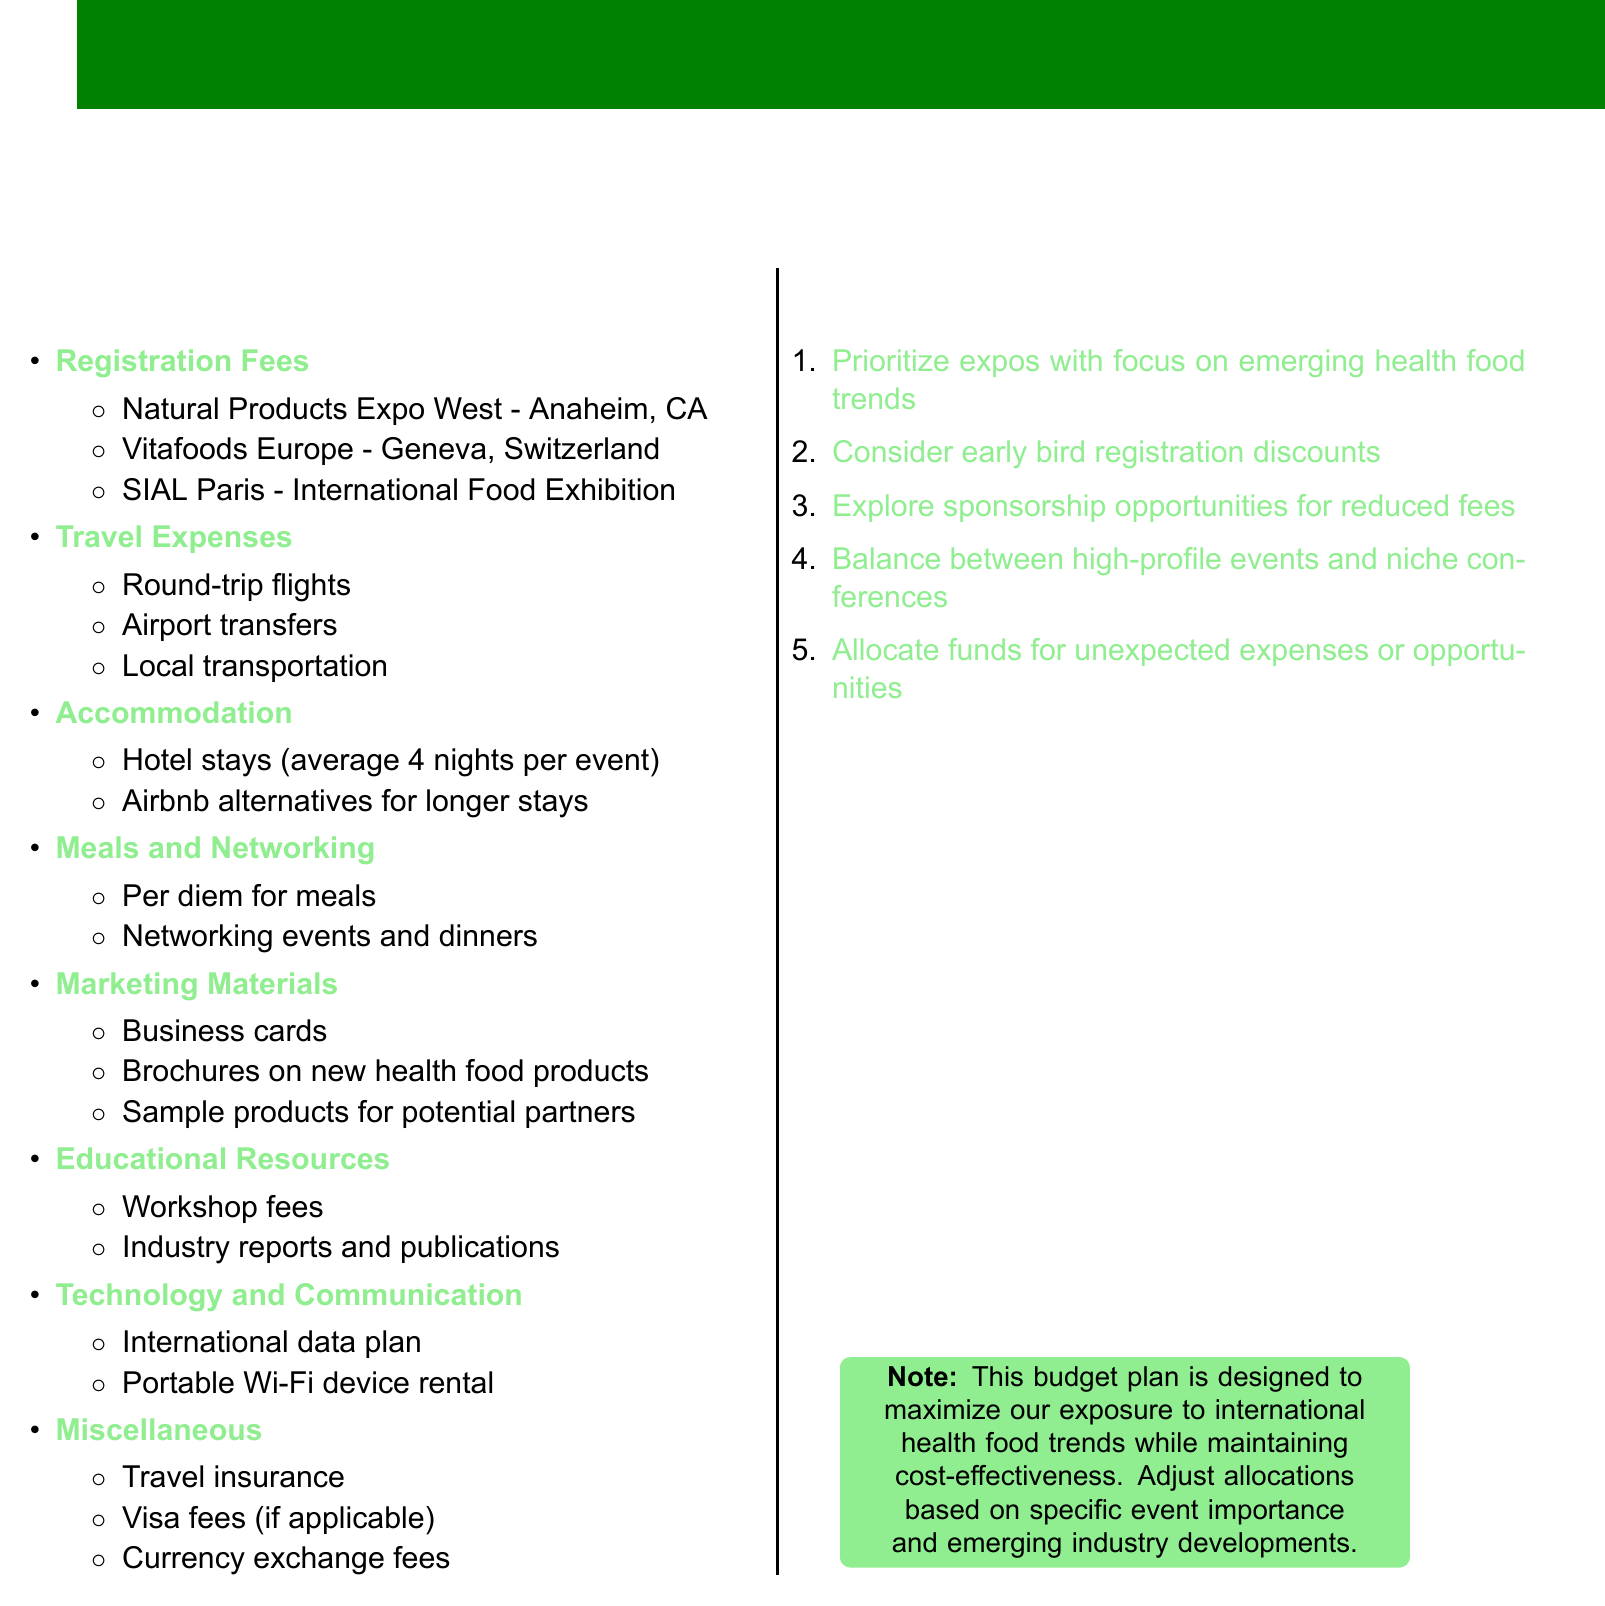What are the three events listed under registration fees? The document lists three events: Natural Products Expo West, Vitafoods Europe, and SIAL Paris.
Answer: Natural Products Expo West, Vitafoods Europe, SIAL Paris What is included in travel expenses? Travel expenses encompass round-trip flights, airport transfers, and local transportation.
Answer: Round-trip flights, airport transfers, local transportation How long is the average stay for hotels per event? The document specifies that the average hotel stay is 4 nights per event.
Answer: 4 nights What is one type of marketing material mentioned? The document includes business cards as a type of marketing material.
Answer: Business cards What is a budget consideration regarding expo selection? A budget consideration is to prioritize expos focused on emerging health food trends.
Answer: Prioritize expos with focus on emerging health food trends What is one item listed under miscellaneous expenses? The document lists travel insurance as an item under miscellaneous expenses.
Answer: Travel insurance How can early registration impact costs? The document mentions considering early bird registration discounts to reduce costs.
Answer: Early bird registration discounts What should be allocated for unexpected expenses? The document advises allocating funds for unexpected expenses or opportunities.
Answer: Unexpected expenses or opportunities 